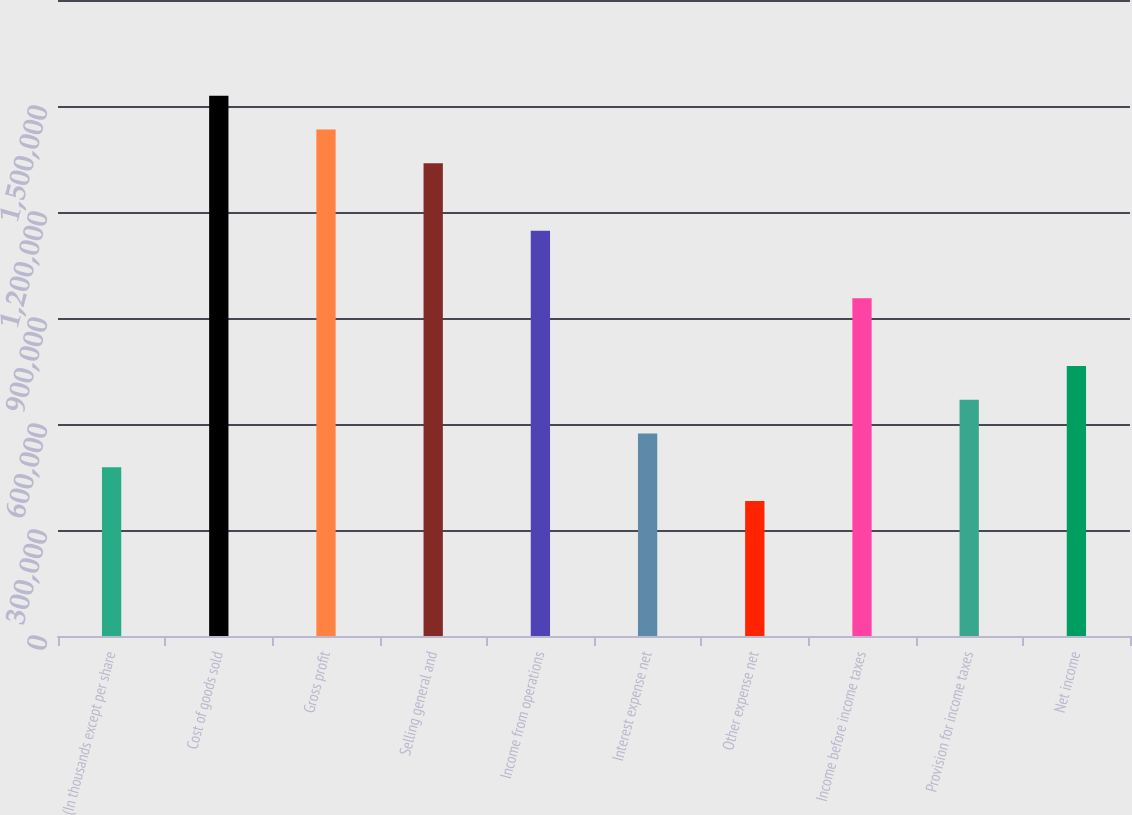<chart> <loc_0><loc_0><loc_500><loc_500><bar_chart><fcel>(In thousands except per share<fcel>Cost of goods sold<fcel>Gross profit<fcel>Selling general and<fcel>Income from operations<fcel>Interest expense net<fcel>Other expense net<fcel>Income before income taxes<fcel>Provision for income taxes<fcel>Net income<nl><fcel>477812<fcel>1.529e+06<fcel>1.43344e+06<fcel>1.33787e+06<fcel>1.14675e+06<fcel>573375<fcel>382250<fcel>955624<fcel>668937<fcel>764499<nl></chart> 